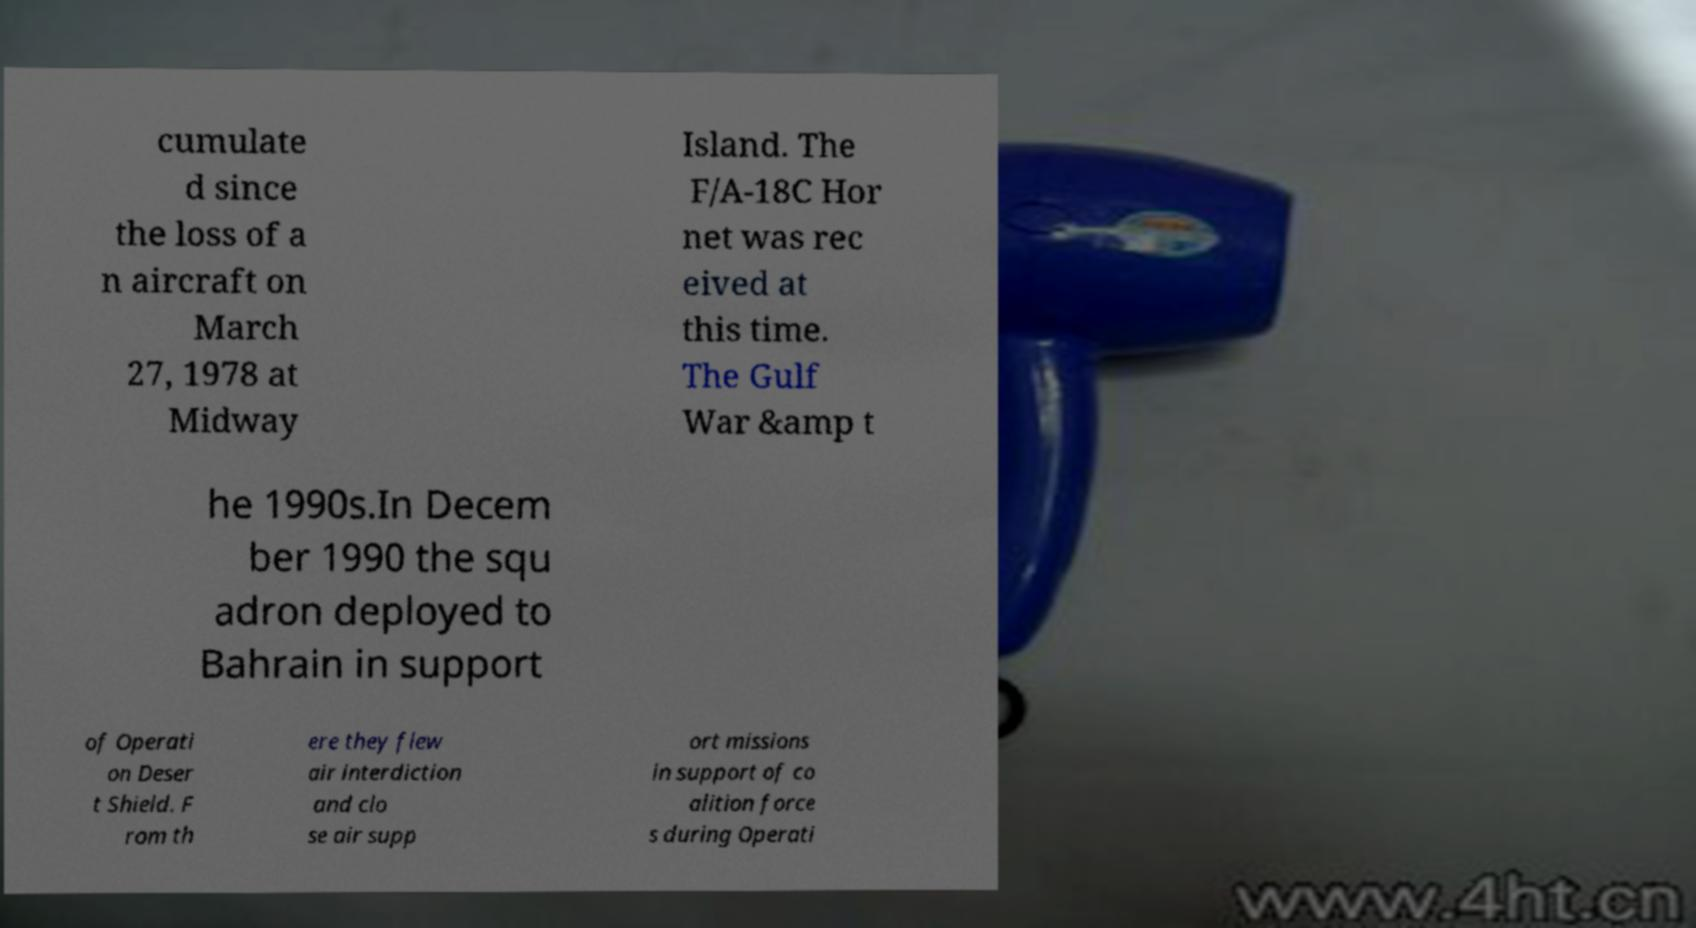Please read and relay the text visible in this image. What does it say? cumulate d since the loss of a n aircraft on March 27, 1978 at Midway Island. The F/A-18C Hor net was rec eived at this time. The Gulf War &amp t he 1990s.In Decem ber 1990 the squ adron deployed to Bahrain in support of Operati on Deser t Shield. F rom th ere they flew air interdiction and clo se air supp ort missions in support of co alition force s during Operati 